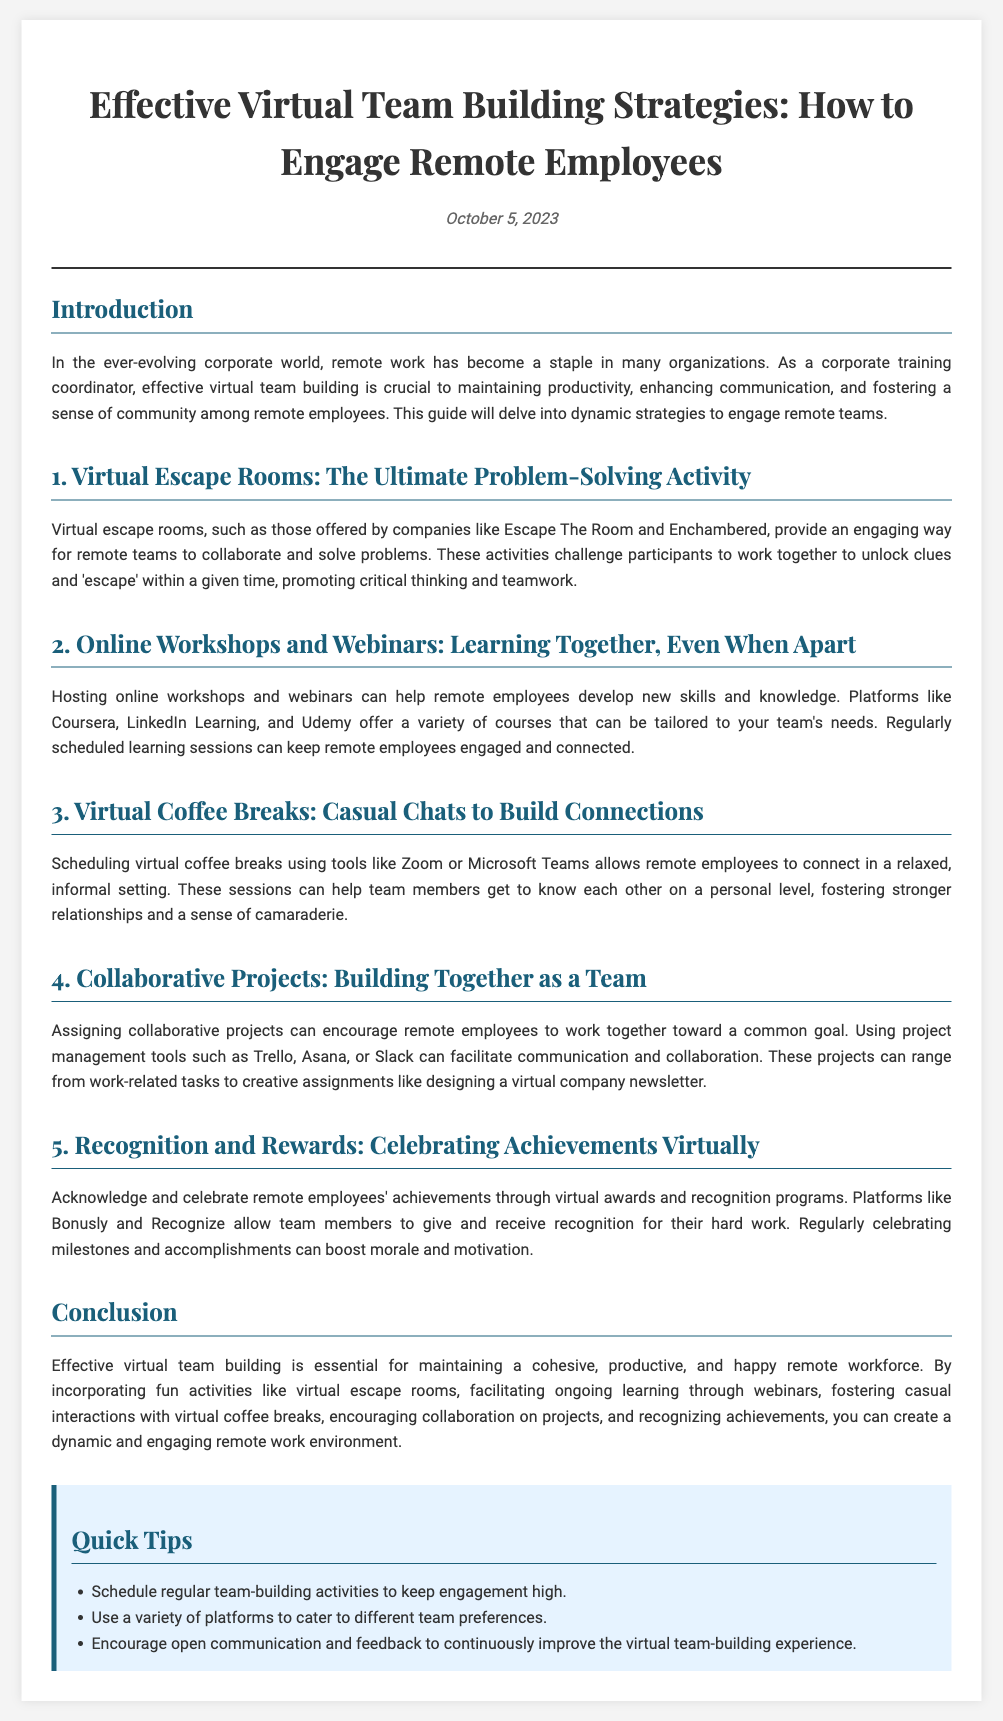What is the title of the article? The title of the article is presented prominently at the top of the document.
Answer: Effective Virtual Team Building Strategies: How to Engage Remote Employees When was the article published? The publication date is mentioned just below the title in the header section.
Answer: October 5, 2023 How many main strategies are discussed in the article? The number of main strategies can be counted from the section titles listed throughout the document.
Answer: Five What platform is suggested for hosting online workshops? The platforms mentioned for hosting workshops are discussed in the relevant section of the article.
Answer: Coursera What type of activity is a Virtual Escape Room categorized as? The description of Virtual Escape Rooms indicates they are a specific type of team-building activity.
Answer: Problem-Solving Activity Which tool is recommended for casual virtual coffee breaks? The tool used for scheduling informal chats among employees is specified in the relevant section.
Answer: Zoom What is included in the Quick Tips section? The Quick Tips section summarizes practical advice that can be easily found listed at the end of the article.
Answer: Regular team-building activities What is the purpose of recognition and rewards in a virtual team? The document discusses the intent behind recognition and rewards in a particular section.
Answer: Celebrating Achievements What is the main objective of effective virtual team building? The conclusion of the document clarifies the overall goal of employing the strategies discussed.
Answer: Maintaining a cohesive, productive, and happy remote workforce 